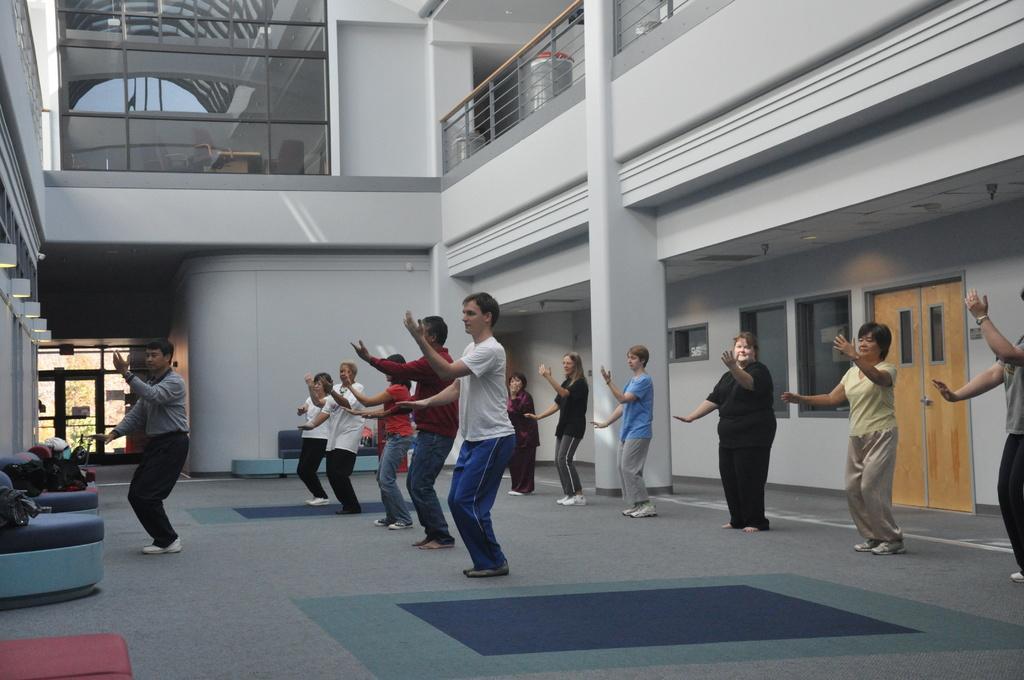How would you summarize this image in a sentence or two? In this image there are people dancing on the floor. At the bottom of the image there are mats on the surface. In front of them there are chairs. On top of it there are a few objects. In the background of the image there is a glass window through which we can see the tables, chairs. On the right side of the image there are trash cans. There is a railing. There is a door. There are glass windows. There is a wall. On the left side of the image there are lights. There is a glass door through which we can see trees. 